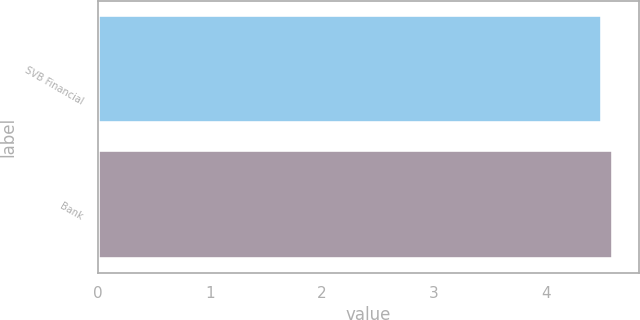Convert chart to OTSL. <chart><loc_0><loc_0><loc_500><loc_500><bar_chart><fcel>SVB Financial<fcel>Bank<nl><fcel>4.5<fcel>4.6<nl></chart> 